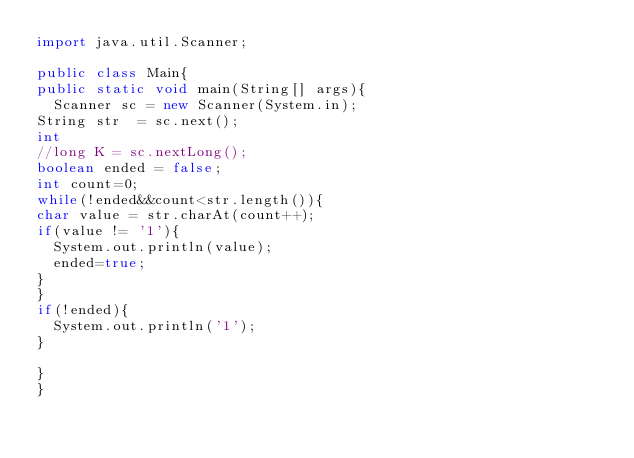<code> <loc_0><loc_0><loc_500><loc_500><_Java_>import java.util.Scanner;

public class Main{
public static void main(String[] args){
  Scanner sc = new Scanner(System.in);
String str  = sc.next();
int
//long K = sc.nextLong();
boolean ended = false;
int count=0;
while(!ended&&count<str.length()){
char value = str.charAt(count++);
if(value != '1'){
  System.out.println(value);
  ended=true;
}
}
if(!ended){
  System.out.println('1');
}

}
}
</code> 